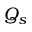Convert formula to latex. <formula><loc_0><loc_0><loc_500><loc_500>Q _ { s }</formula> 